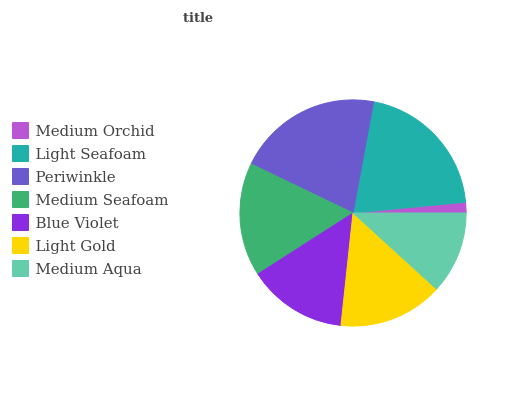Is Medium Orchid the minimum?
Answer yes or no. Yes. Is Periwinkle the maximum?
Answer yes or no. Yes. Is Light Seafoam the minimum?
Answer yes or no. No. Is Light Seafoam the maximum?
Answer yes or no. No. Is Light Seafoam greater than Medium Orchid?
Answer yes or no. Yes. Is Medium Orchid less than Light Seafoam?
Answer yes or no. Yes. Is Medium Orchid greater than Light Seafoam?
Answer yes or no. No. Is Light Seafoam less than Medium Orchid?
Answer yes or no. No. Is Light Gold the high median?
Answer yes or no. Yes. Is Light Gold the low median?
Answer yes or no. Yes. Is Medium Aqua the high median?
Answer yes or no. No. Is Medium Orchid the low median?
Answer yes or no. No. 